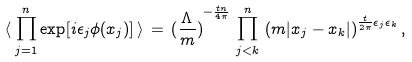<formula> <loc_0><loc_0><loc_500><loc_500>\langle \, \prod _ { j = 1 } ^ { n } \exp [ i \epsilon _ { j } \phi ( x _ { j } ) ] \, \rangle \, = \, { ( \frac { \Lambda } { m } ) } ^ { - \frac { t n } { 4 \pi } } \, \prod _ { j < k } ^ { n } \, { ( m | x _ { j } - x _ { k } | ) } ^ { \frac { t } { 2 \pi } \epsilon _ { j } \epsilon _ { k } } \, ,</formula> 